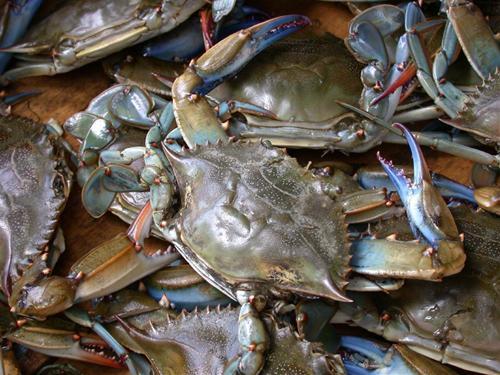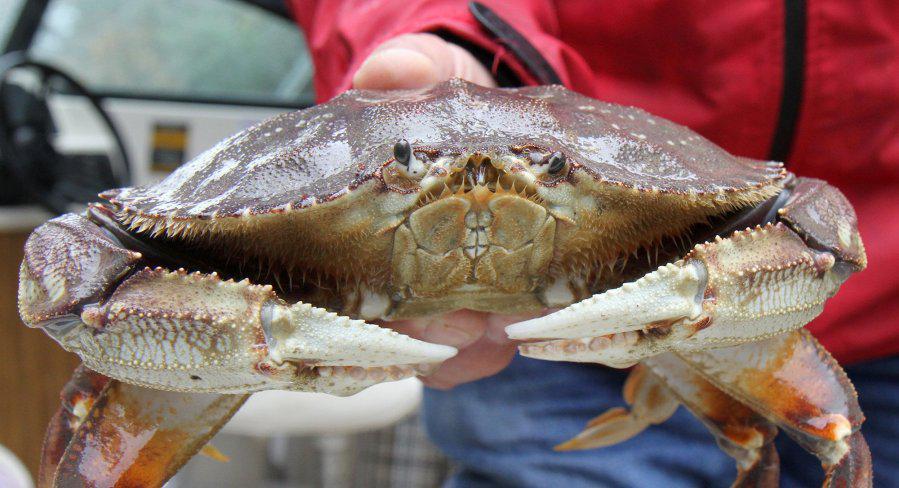The first image is the image on the left, the second image is the image on the right. Analyze the images presented: Is the assertion "There are exactly two live crabs." valid? Answer yes or no. No. The first image is the image on the left, the second image is the image on the right. For the images displayed, is the sentence "A single crab sits on a sediment surface in the image on the right." factually correct? Answer yes or no. No. 